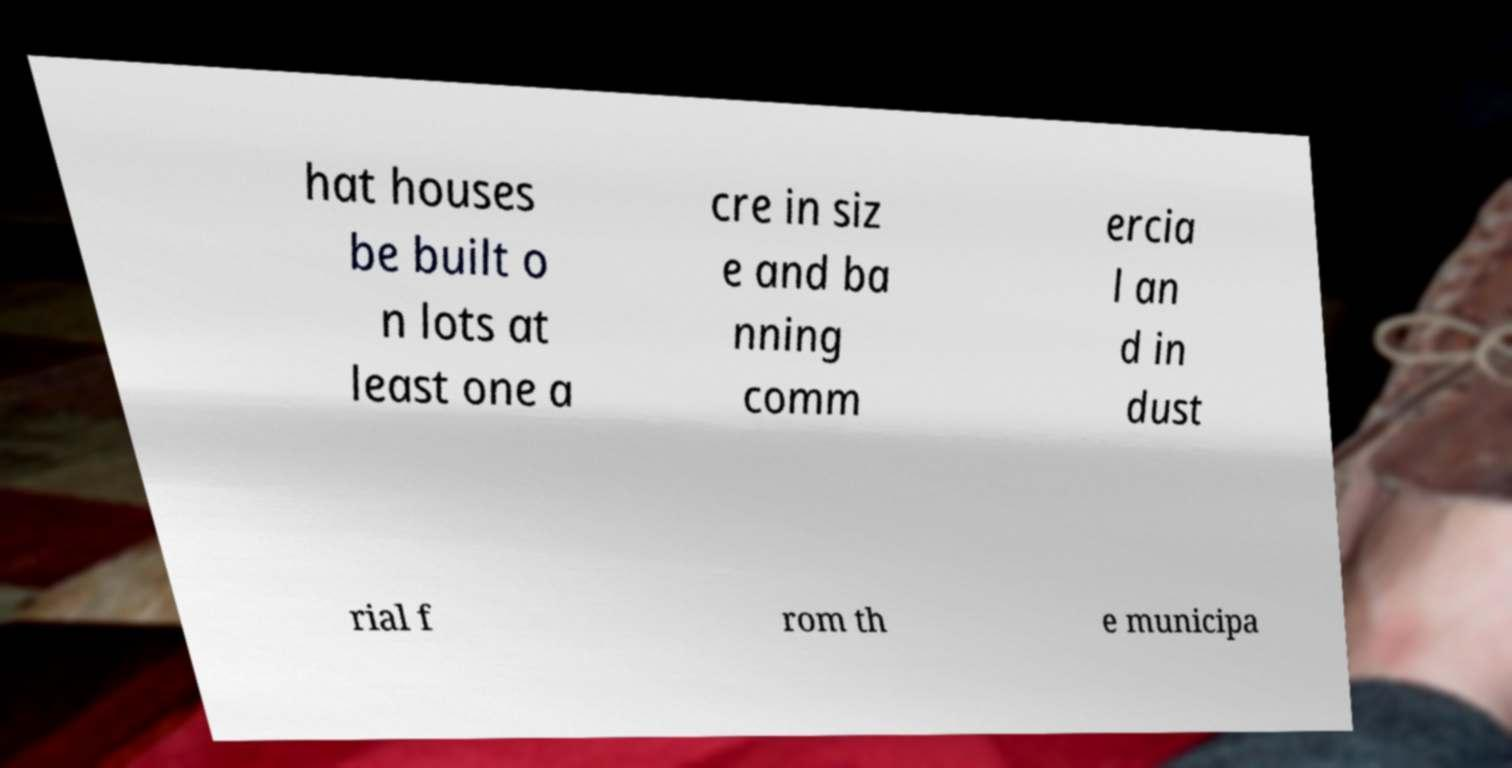Could you extract and type out the text from this image? hat houses be built o n lots at least one a cre in siz e and ba nning comm ercia l an d in dust rial f rom th e municipa 